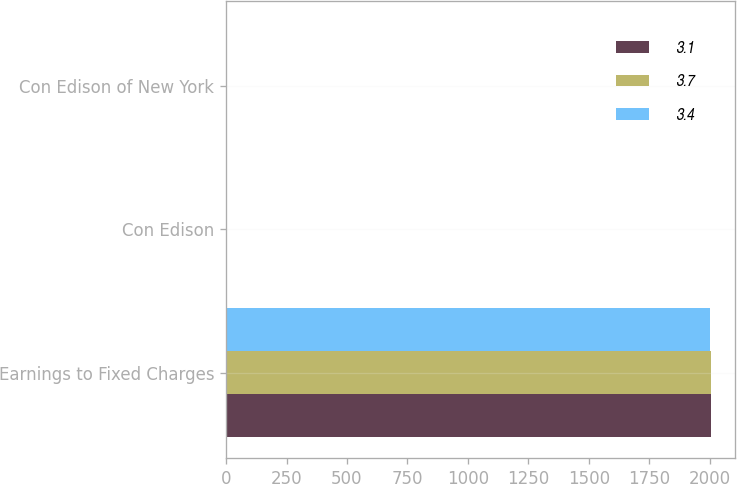Convert chart to OTSL. <chart><loc_0><loc_0><loc_500><loc_500><stacked_bar_chart><ecel><fcel>Earnings to Fixed Charges<fcel>Con Edison<fcel>Con Edison of New York<nl><fcel>3.1<fcel>2005<fcel>3.1<fcel>3.7<nl><fcel>3.7<fcel>2004<fcel>2.6<fcel>3.1<nl><fcel>3.4<fcel>2003<fcel>3.1<fcel>3.4<nl></chart> 